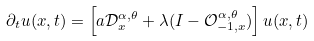Convert formula to latex. <formula><loc_0><loc_0><loc_500><loc_500>\partial _ { t } u ( x , t ) = \left [ a \mathcal { D } _ { x } ^ { \alpha , \theta } + \lambda ( I - \mathcal { O } _ { - 1 , x } ^ { \alpha , \theta } ) \right ] u ( x , t )</formula> 